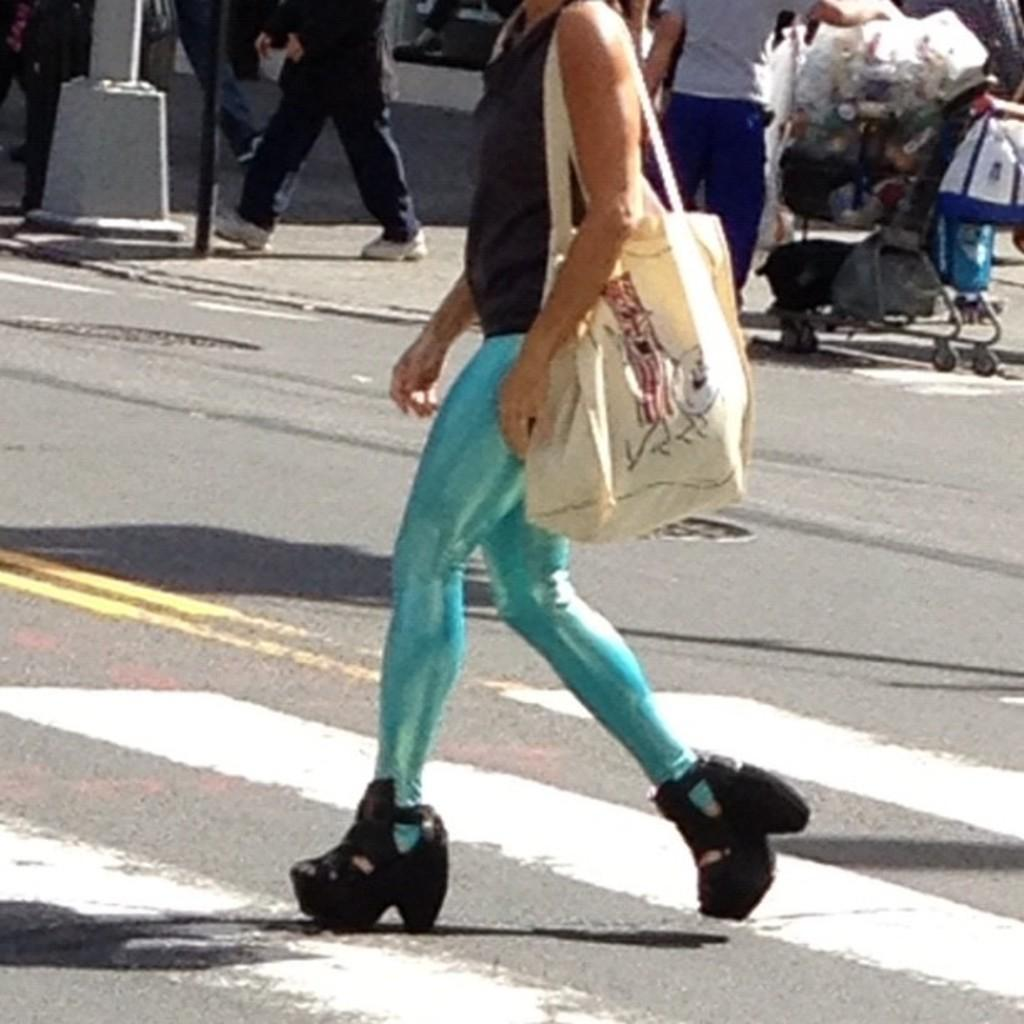What is the main action of the person in the image? There is a person walking in the image. Can you describe the clothing of the person? The person is wearing a black and blue color dress. What can be seen in the background of the image? There are other persons walking in the background of the image, as well as poles. What type of truck can be seen in the image? There is no truck present in the image. What impulse might the person walking be experiencing in the image? It is impossible to determine the person's impulses or emotions from the image alone. --- Facts: 1. There is a person sitting on a chair in the image. 2. The person is holding a book. 3. The book has a red cover. 4. There is a table next to the chair. 5. There is a lamp on the table. Absurd Topics: parrot, dance, ocean Conversation: What is the person in the image doing? The person is sitting on a chair in the image. What is the person holding? The person is holding a book. Can you describe the book? The book has a red cover. What is located next to the chair? There is a table next to the chair. What is on the table? There is a lamp on the table. Reasoning: Let's think step by step in order to produce the conversation. We start by identifying the main action of the person in the image, which is sitting. Then, we describe the object the person is holding, which is a book with a red cover. Next, we mention the presence of a table next to the chair and a lamp on the table. Absurd Question/Answer: Can you tell me how many parrots are sitting on the person's shoulder in the image? There are no parrots present in the image. What type of dance is the person performing in the image? There is no indication of the person dancing in the image. 